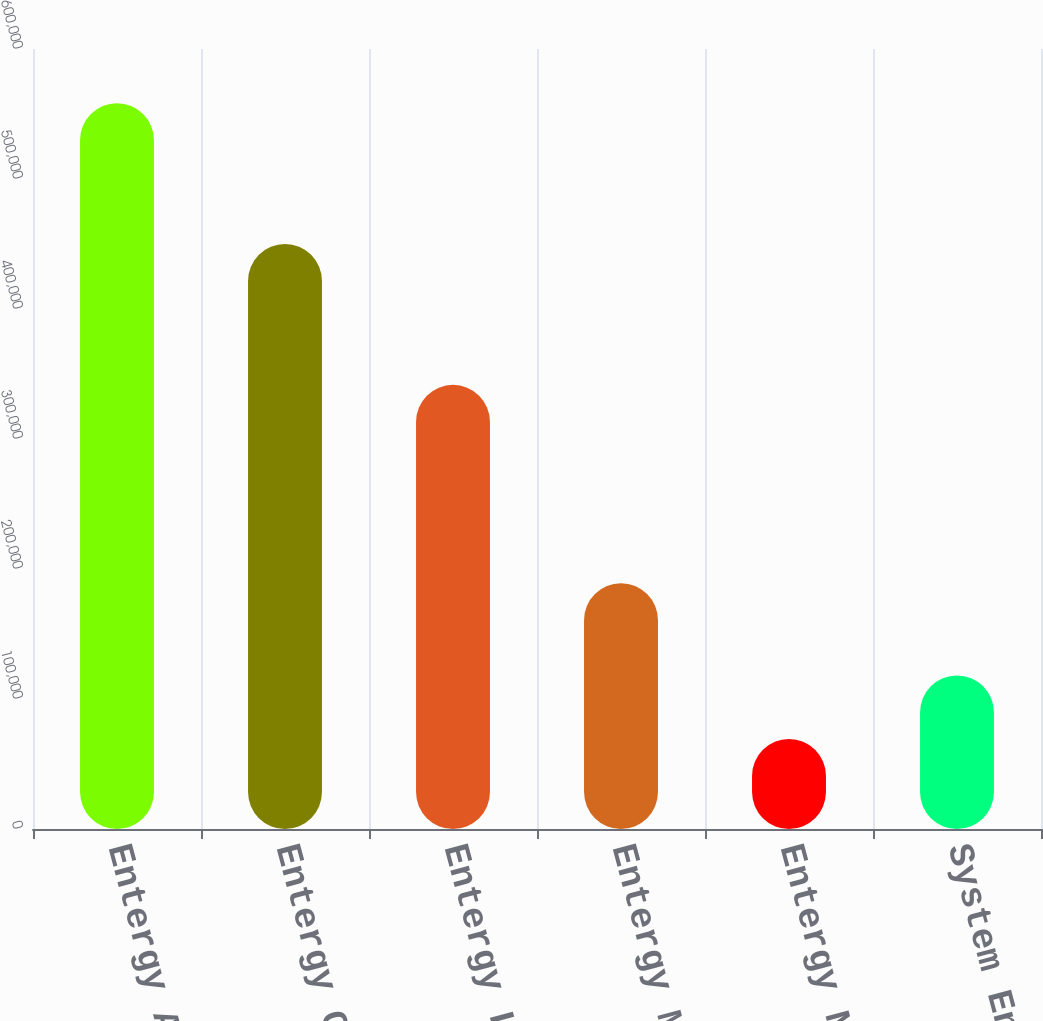Convert chart to OTSL. <chart><loc_0><loc_0><loc_500><loc_500><bar_chart><fcel>Entergy Arkansas<fcel>Entergy Gulf States<fcel>Entergy Louisiana<fcel>Entergy Mississippi<fcel>Entergy New Orleans<fcel>System Energy<nl><fcel>558283<fcel>449986<fcel>341681<fcel>189119<fcel>69202<fcel>118110<nl></chart> 